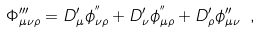<formula> <loc_0><loc_0><loc_500><loc_500>\Phi _ { \mu \nu \rho } ^ { \prime \prime \prime } = D _ { \mu } ^ { \prime } \phi _ { \nu \rho } ^ { ^ { \prime \prime } } + D _ { \nu } ^ { \prime } \phi _ { \mu \rho } ^ { ^ { \prime \prime } } + D _ { \rho } ^ { \prime } \phi _ { \mu \nu } ^ { \prime \prime } \text { } , \text { \quad }</formula> 